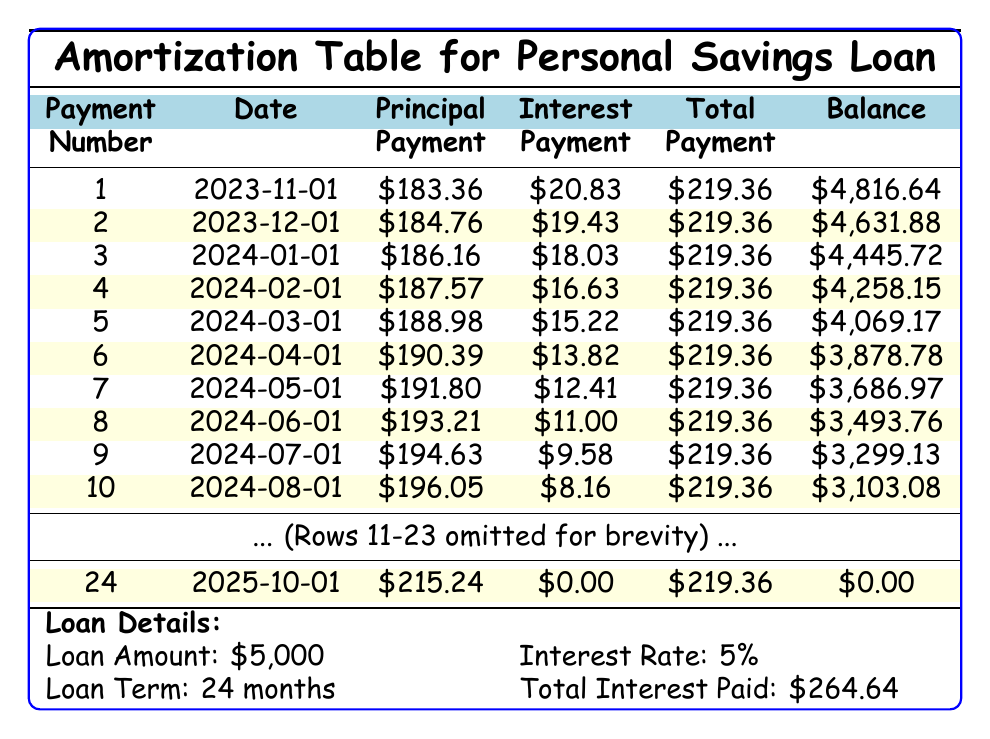What is the total amount paid by the end of the loan? The total payment is specified in the table as $5,264.64. This number represents the entire amount that the borrower will pay over the loan term, including both principal and interest.
Answer: 5264.64 What is the monthly payment amount? The monthly payment is presented in the table as $219.36. This value is the fixed amount the borrower will pay each month throughout the duration of the loan.
Answer: 219.36 How much interest is paid in the first month? The interest payment for the first month is listed as $20.83. This value denotes the portion of the first monthly payment that goes towards paying interest on the loan.
Answer: 20.83 Is the principal payment in the second month greater than the principal payment in the first month? The principal payment for the second month is $184.76, while the first month is $183.36. Since $184.76 is greater than $183.36, the statement is true.
Answer: Yes What is the remaining balance after the 12th payment? The remaining balance after the 12th payment is $2,706.72, as indicated in the table for the 12th payment number. This value shows how much of the loan is still owed after making 12 payments.
Answer: 2706.72 What is the total principal paid by the end of the loan? The total principal payment over the entire loan is the sum of each principal payment for all 24 months. Adding each monthly principal payment gives a total of $5,000, which indicates that the entire loan amount will be repaid by the end of the term.
Answer: 5000 How much interest is paid in the last month? The interest payment in the last month (24th payment) is $0.00, as shown in the table. This occurs because by the last payment, the principal is fully paid off, and there is no remaining balance to accrue interest.
Answer: 0.00 What is the principal payment difference between the 24th month and the 1st month? The principal payment for the 24th month is $215.24 and for the 1st month it is $183.36. The difference is calculated as $215.24 - $183.36 = $31.88 showing how much more was paid in principal in the last month compared to the first month.
Answer: 31.88 How many payments include an interest payment greater than $10? By reviewing the table, payments 1 to 9 each have an interest payment greater than $10, but payments 10 to 12 gradually decrease below $10. Counting these payments confirms there are 9 payments with interest over $10.
Answer: 9 